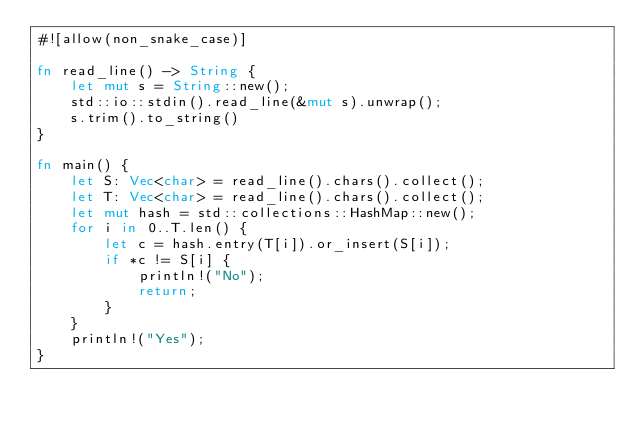<code> <loc_0><loc_0><loc_500><loc_500><_Rust_>#![allow(non_snake_case)]

fn read_line() -> String {
    let mut s = String::new();
    std::io::stdin().read_line(&mut s).unwrap();
    s.trim().to_string()
}

fn main() {
    let S: Vec<char> = read_line().chars().collect();
    let T: Vec<char> = read_line().chars().collect();
    let mut hash = std::collections::HashMap::new();
    for i in 0..T.len() {
        let c = hash.entry(T[i]).or_insert(S[i]);
        if *c != S[i] {
            println!("No");
            return;
        }
    }
    println!("Yes");
}
</code> 